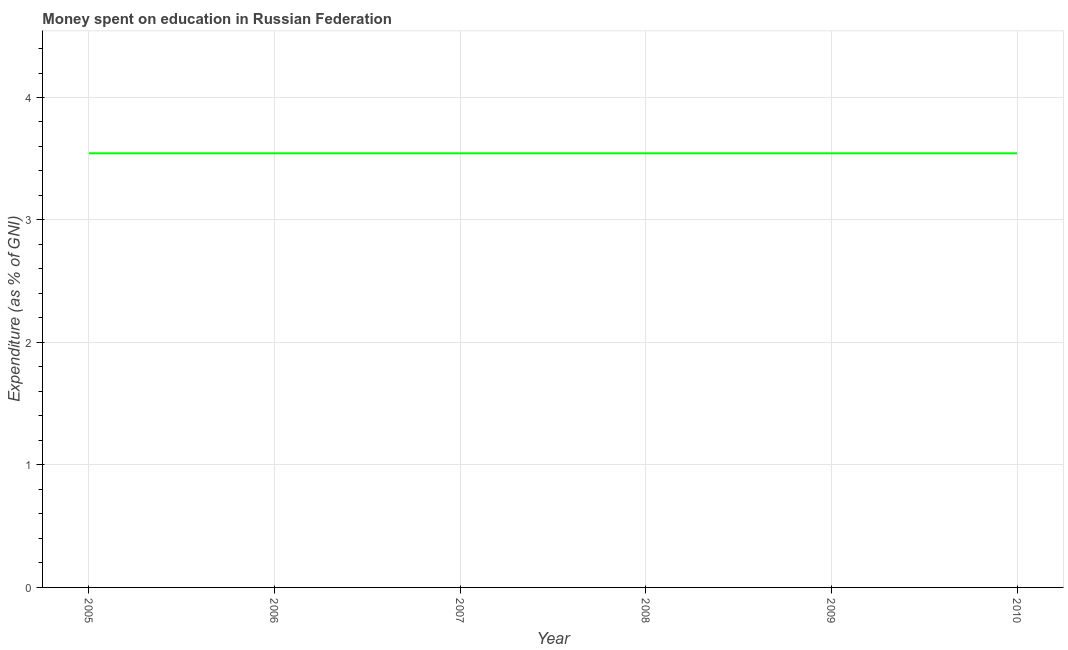What is the expenditure on education in 2009?
Make the answer very short. 3.54. Across all years, what is the maximum expenditure on education?
Your answer should be compact. 3.54. Across all years, what is the minimum expenditure on education?
Your response must be concise. 3.54. In which year was the expenditure on education maximum?
Your response must be concise. 2005. What is the sum of the expenditure on education?
Keep it short and to the point. 21.27. What is the average expenditure on education per year?
Make the answer very short. 3.54. What is the median expenditure on education?
Provide a succinct answer. 3.54. What is the ratio of the expenditure on education in 2005 to that in 2010?
Ensure brevity in your answer.  1. Is the expenditure on education in 2005 less than that in 2006?
Provide a short and direct response. No. Is the sum of the expenditure on education in 2007 and 2008 greater than the maximum expenditure on education across all years?
Offer a very short reply. Yes. In how many years, is the expenditure on education greater than the average expenditure on education taken over all years?
Keep it short and to the point. 0. How many lines are there?
Give a very brief answer. 1. What is the difference between two consecutive major ticks on the Y-axis?
Your answer should be very brief. 1. Are the values on the major ticks of Y-axis written in scientific E-notation?
Offer a very short reply. No. Does the graph contain any zero values?
Give a very brief answer. No. Does the graph contain grids?
Provide a short and direct response. Yes. What is the title of the graph?
Your response must be concise. Money spent on education in Russian Federation. What is the label or title of the X-axis?
Give a very brief answer. Year. What is the label or title of the Y-axis?
Ensure brevity in your answer.  Expenditure (as % of GNI). What is the Expenditure (as % of GNI) of 2005?
Keep it short and to the point. 3.54. What is the Expenditure (as % of GNI) in 2006?
Ensure brevity in your answer.  3.54. What is the Expenditure (as % of GNI) of 2007?
Keep it short and to the point. 3.54. What is the Expenditure (as % of GNI) of 2008?
Your response must be concise. 3.54. What is the Expenditure (as % of GNI) of 2009?
Offer a terse response. 3.54. What is the Expenditure (as % of GNI) of 2010?
Your answer should be compact. 3.54. What is the difference between the Expenditure (as % of GNI) in 2005 and 2006?
Your answer should be very brief. 0. What is the difference between the Expenditure (as % of GNI) in 2005 and 2009?
Keep it short and to the point. 0. What is the difference between the Expenditure (as % of GNI) in 2006 and 2007?
Your answer should be very brief. 0. What is the difference between the Expenditure (as % of GNI) in 2006 and 2008?
Keep it short and to the point. 0. What is the difference between the Expenditure (as % of GNI) in 2006 and 2009?
Provide a short and direct response. 0. What is the difference between the Expenditure (as % of GNI) in 2006 and 2010?
Give a very brief answer. 0. What is the difference between the Expenditure (as % of GNI) in 2007 and 2009?
Your answer should be compact. 0. What is the difference between the Expenditure (as % of GNI) in 2008 and 2009?
Ensure brevity in your answer.  0. What is the difference between the Expenditure (as % of GNI) in 2008 and 2010?
Provide a succinct answer. 0. What is the ratio of the Expenditure (as % of GNI) in 2005 to that in 2006?
Provide a succinct answer. 1. What is the ratio of the Expenditure (as % of GNI) in 2005 to that in 2008?
Ensure brevity in your answer.  1. What is the ratio of the Expenditure (as % of GNI) in 2005 to that in 2009?
Keep it short and to the point. 1. What is the ratio of the Expenditure (as % of GNI) in 2005 to that in 2010?
Offer a terse response. 1. What is the ratio of the Expenditure (as % of GNI) in 2006 to that in 2007?
Offer a very short reply. 1. What is the ratio of the Expenditure (as % of GNI) in 2006 to that in 2008?
Your response must be concise. 1. What is the ratio of the Expenditure (as % of GNI) in 2006 to that in 2009?
Offer a very short reply. 1. What is the ratio of the Expenditure (as % of GNI) in 2006 to that in 2010?
Make the answer very short. 1. What is the ratio of the Expenditure (as % of GNI) in 2007 to that in 2008?
Provide a short and direct response. 1. What is the ratio of the Expenditure (as % of GNI) in 2007 to that in 2009?
Your answer should be compact. 1. What is the ratio of the Expenditure (as % of GNI) in 2009 to that in 2010?
Make the answer very short. 1. 